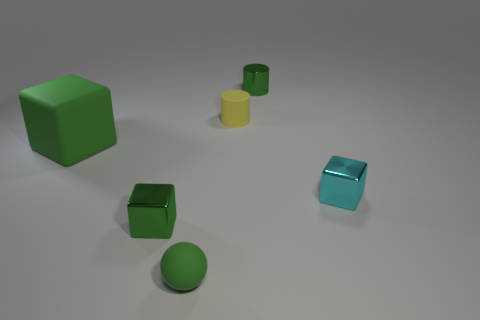Subtract all big blocks. How many blocks are left? 2 Subtract all cyan cubes. How many cubes are left? 2 Subtract 1 balls. How many balls are left? 0 Add 1 big blue matte balls. How many objects exist? 7 Subtract all cyan spheres. Subtract all blue cubes. How many spheres are left? 1 Subtract all yellow cubes. How many blue cylinders are left? 0 Subtract all green shiny cylinders. Subtract all tiny green metallic cubes. How many objects are left? 4 Add 6 green metallic cylinders. How many green metallic cylinders are left? 7 Add 1 yellow metal balls. How many yellow metal balls exist? 1 Subtract 0 cyan spheres. How many objects are left? 6 